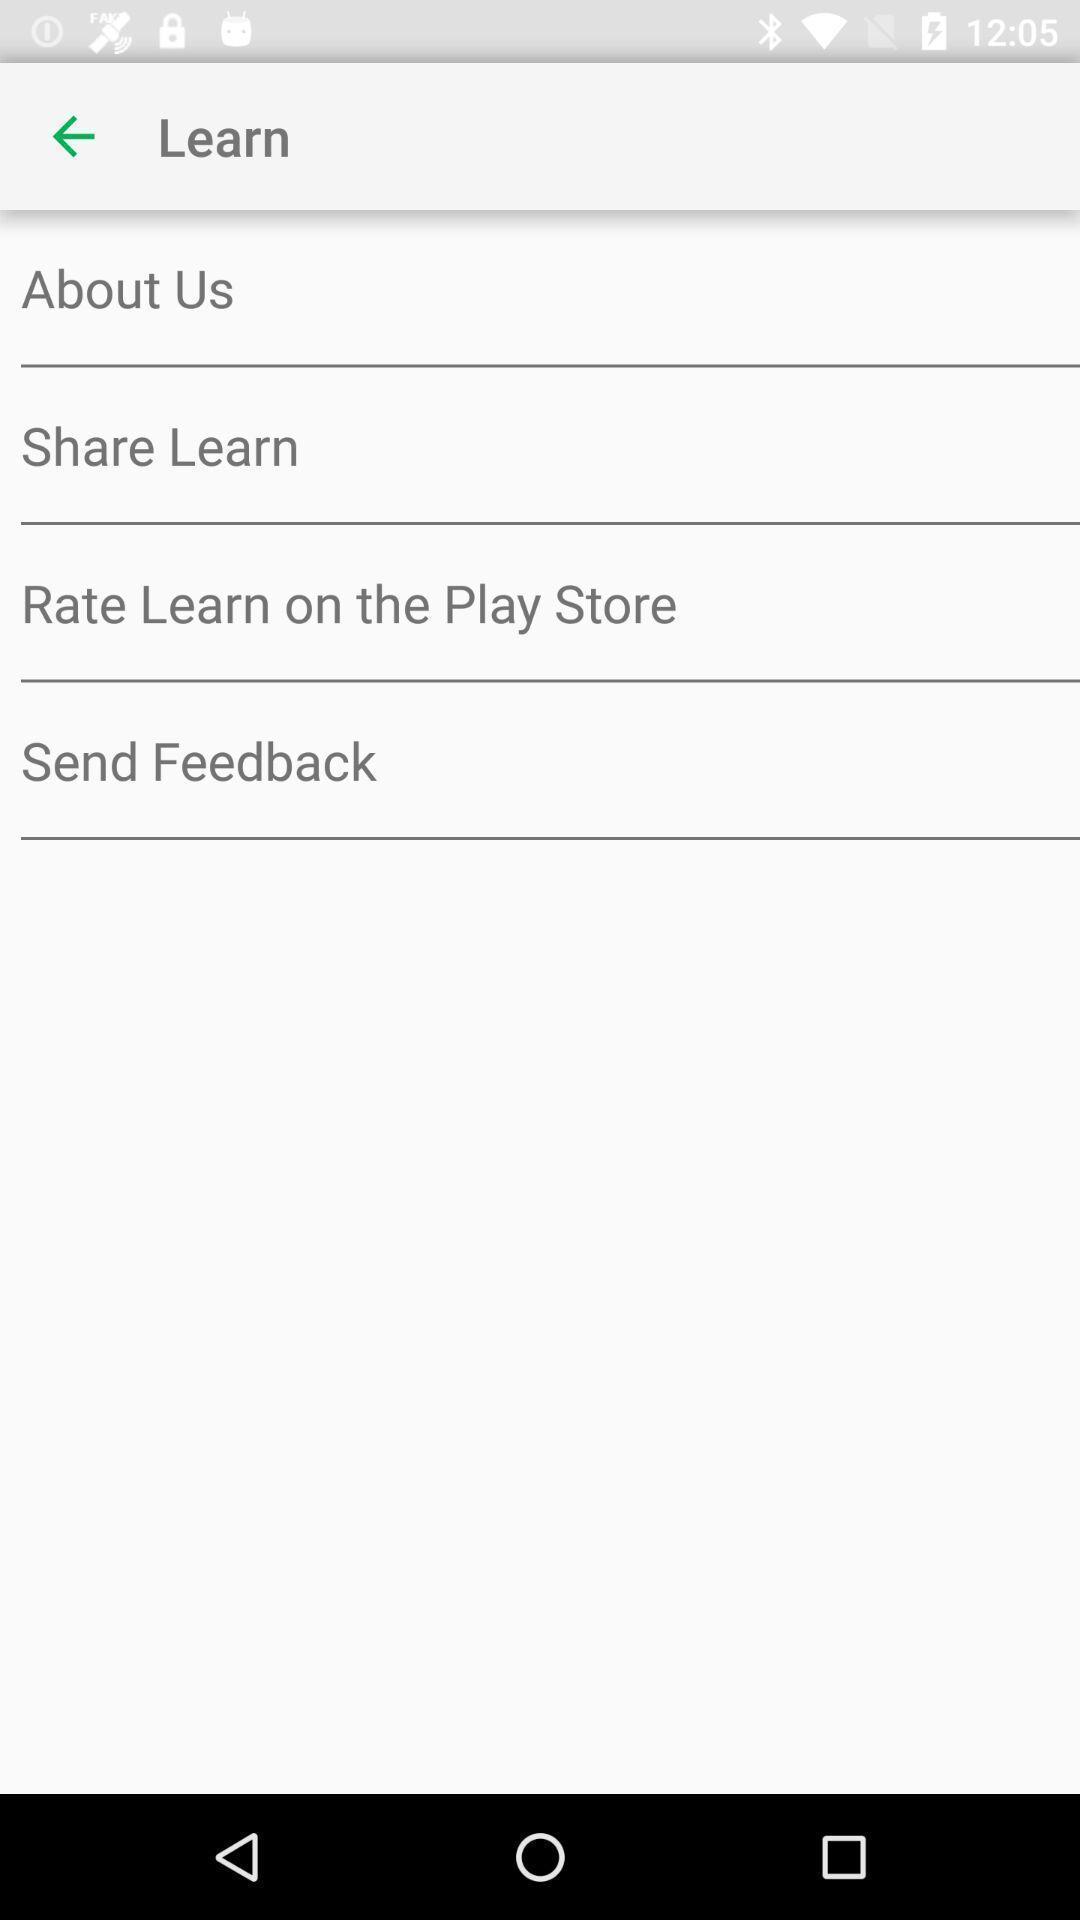Provide a detailed account of this screenshot. Page showing options related to a stocks learning app. 